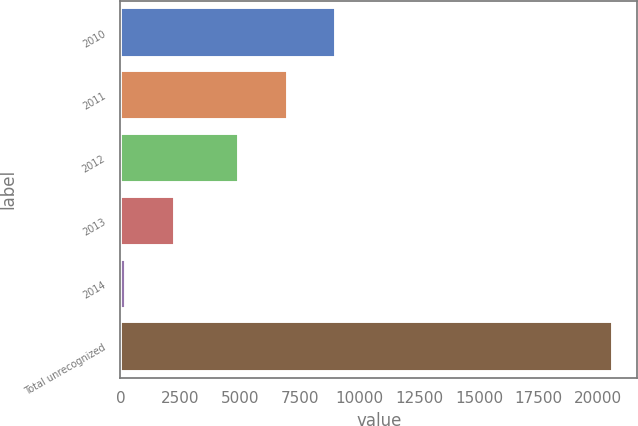Convert chart. <chart><loc_0><loc_0><loc_500><loc_500><bar_chart><fcel>2010<fcel>2011<fcel>2012<fcel>2013<fcel>2014<fcel>Total unrecognized<nl><fcel>9040.6<fcel>7004.8<fcel>4969<fcel>2282.8<fcel>247<fcel>20605<nl></chart> 